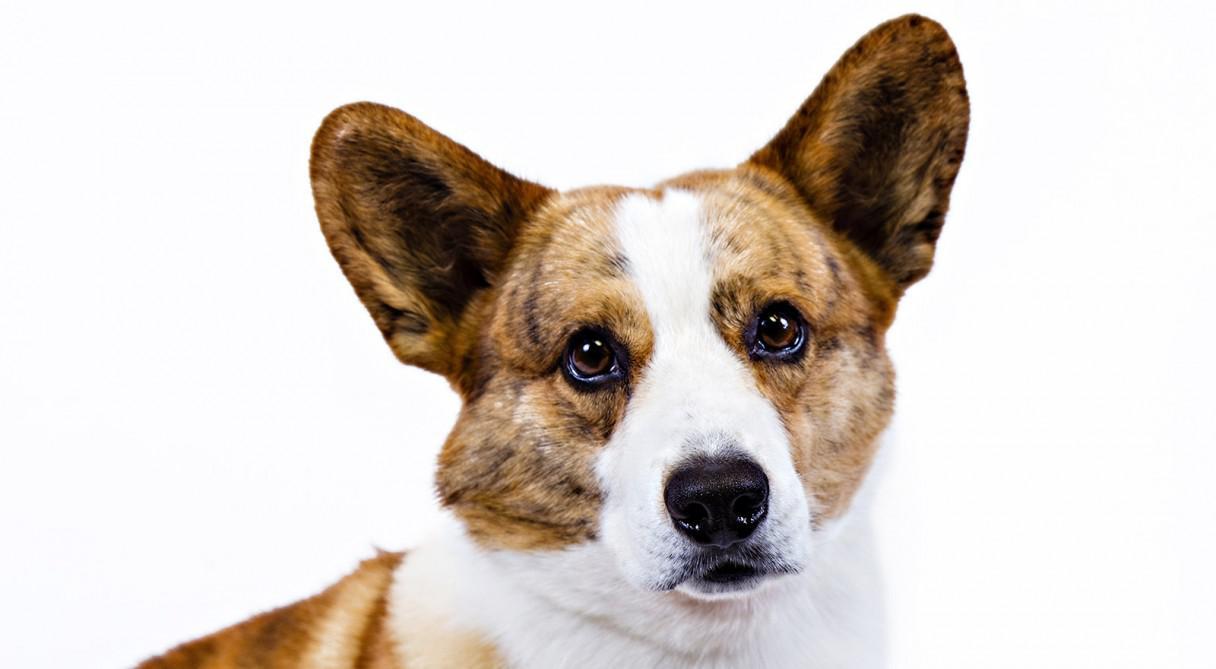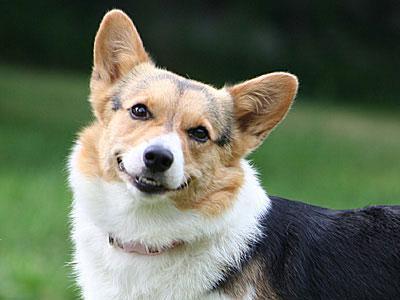The first image is the image on the left, the second image is the image on the right. Examine the images to the left and right. Is the description "All dogs shown are on the grass, and at least two dogs in total have their mouths open and tongues showing." accurate? Answer yes or no. No. The first image is the image on the left, the second image is the image on the right. Examine the images to the left and right. Is the description "At least one dog is sticking the tongue out." accurate? Answer yes or no. No. 